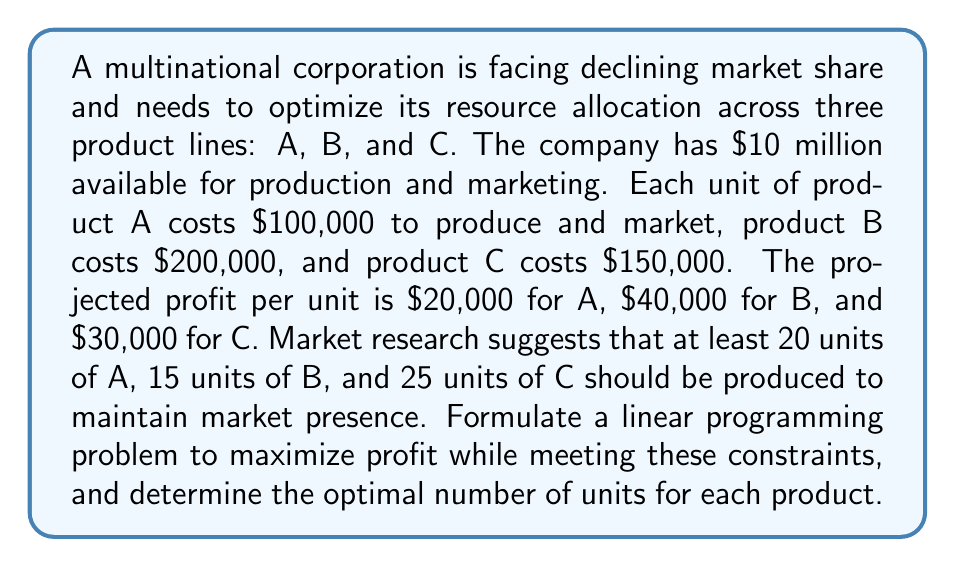Show me your answer to this math problem. Let's approach this step-by-step:

1) Define variables:
   Let $x$, $y$, and $z$ be the number of units produced for products A, B, and C respectively.

2) Objective function:
   Maximize profit: $f(x,y,z) = 20000x + 40000y + 30000z$

3) Constraints:
   a) Budget constraint: $100000x + 200000y + 150000z \leq 10000000$
   b) Minimum production constraints:
      $x \geq 20$
      $y \geq 15$
      $z \geq 25$
   c) Non-negativity constraints:
      $x, y, z \geq 0$

4) Linear Programming Problem:
   Maximize: $f(x,y,z) = 20000x + 40000y + 30000z$
   Subject to:
   $$\begin{align*}
   100000x + 200000y + 150000z &\leq 10000000 \\
   x &\geq 20 \\
   y &\geq 15 \\
   z &\geq 25 \\
   x, y, z &\geq 0
   \end{align*}$$

5) Solve using the simplex method or linear programming software.

6) The optimal solution is:
   $x = 20$, $y = 15$, $z = 40$

7) Verification:
   Budget used: $100000(20) + 200000(15) + 150000(40) = 10000000$
   Profit: $20000(20) + 40000(15) + 30000(40) = 2200000$

This solution maximizes profit while meeting all constraints.
Answer: Product A: 20 units, Product B: 15 units, Product C: 40 units 